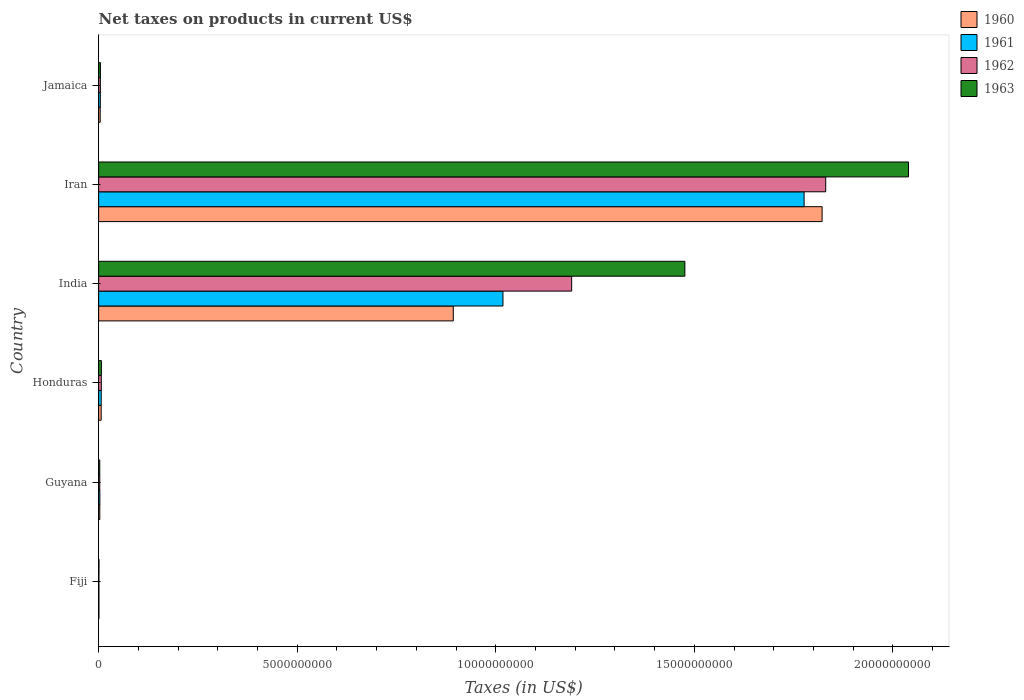How many different coloured bars are there?
Provide a short and direct response. 4. Are the number of bars per tick equal to the number of legend labels?
Provide a succinct answer. Yes. Are the number of bars on each tick of the Y-axis equal?
Keep it short and to the point. Yes. How many bars are there on the 3rd tick from the bottom?
Your answer should be compact. 4. What is the label of the 5th group of bars from the top?
Ensure brevity in your answer.  Guyana. What is the net taxes on products in 1961 in Iran?
Keep it short and to the point. 1.78e+1. Across all countries, what is the maximum net taxes on products in 1963?
Give a very brief answer. 2.04e+1. Across all countries, what is the minimum net taxes on products in 1963?
Offer a very short reply. 8.90e+06. In which country was the net taxes on products in 1962 maximum?
Offer a very short reply. Iran. In which country was the net taxes on products in 1960 minimum?
Give a very brief answer. Fiji. What is the total net taxes on products in 1960 in the graph?
Your answer should be compact. 2.73e+1. What is the difference between the net taxes on products in 1960 in Guyana and that in Honduras?
Give a very brief answer. -3.51e+07. What is the difference between the net taxes on products in 1960 in Fiji and the net taxes on products in 1961 in Iran?
Provide a short and direct response. -1.78e+1. What is the average net taxes on products in 1963 per country?
Make the answer very short. 5.88e+09. What is the difference between the net taxes on products in 1963 and net taxes on products in 1961 in Iran?
Your answer should be very brief. 2.63e+09. In how many countries, is the net taxes on products in 1962 greater than 10000000000 US$?
Ensure brevity in your answer.  2. What is the ratio of the net taxes on products in 1962 in Fiji to that in Iran?
Provide a short and direct response. 0. Is the difference between the net taxes on products in 1963 in Fiji and India greater than the difference between the net taxes on products in 1961 in Fiji and India?
Ensure brevity in your answer.  No. What is the difference between the highest and the second highest net taxes on products in 1960?
Your answer should be compact. 9.29e+09. What is the difference between the highest and the lowest net taxes on products in 1961?
Your answer should be very brief. 1.78e+1. What does the 4th bar from the top in Fiji represents?
Make the answer very short. 1960. What does the 2nd bar from the bottom in India represents?
Keep it short and to the point. 1961. How many countries are there in the graph?
Ensure brevity in your answer.  6. Are the values on the major ticks of X-axis written in scientific E-notation?
Make the answer very short. No. Does the graph contain any zero values?
Your answer should be very brief. No. Where does the legend appear in the graph?
Offer a very short reply. Top right. How many legend labels are there?
Your response must be concise. 4. What is the title of the graph?
Provide a succinct answer. Net taxes on products in current US$. What is the label or title of the X-axis?
Offer a terse response. Taxes (in US$). What is the label or title of the Y-axis?
Offer a very short reply. Country. What is the Taxes (in US$) of 1960 in Fiji?
Your answer should be compact. 6.80e+06. What is the Taxes (in US$) in 1961 in Fiji?
Offer a terse response. 6.80e+06. What is the Taxes (in US$) in 1962 in Fiji?
Give a very brief answer. 7.40e+06. What is the Taxes (in US$) in 1963 in Fiji?
Offer a terse response. 8.90e+06. What is the Taxes (in US$) of 1960 in Guyana?
Offer a terse response. 2.94e+07. What is the Taxes (in US$) of 1961 in Guyana?
Provide a succinct answer. 3.07e+07. What is the Taxes (in US$) in 1962 in Guyana?
Give a very brief answer. 2.90e+07. What is the Taxes (in US$) of 1963 in Guyana?
Offer a terse response. 2.82e+07. What is the Taxes (in US$) of 1960 in Honduras?
Provide a short and direct response. 6.45e+07. What is the Taxes (in US$) in 1961 in Honduras?
Keep it short and to the point. 6.50e+07. What is the Taxes (in US$) of 1962 in Honduras?
Provide a succinct answer. 6.73e+07. What is the Taxes (in US$) of 1963 in Honduras?
Offer a terse response. 6.96e+07. What is the Taxes (in US$) in 1960 in India?
Keep it short and to the point. 8.93e+09. What is the Taxes (in US$) of 1961 in India?
Give a very brief answer. 1.02e+1. What is the Taxes (in US$) of 1962 in India?
Provide a short and direct response. 1.19e+1. What is the Taxes (in US$) in 1963 in India?
Keep it short and to the point. 1.48e+1. What is the Taxes (in US$) of 1960 in Iran?
Ensure brevity in your answer.  1.82e+1. What is the Taxes (in US$) of 1961 in Iran?
Give a very brief answer. 1.78e+1. What is the Taxes (in US$) of 1962 in Iran?
Give a very brief answer. 1.83e+1. What is the Taxes (in US$) in 1963 in Iran?
Offer a terse response. 2.04e+1. What is the Taxes (in US$) of 1960 in Jamaica?
Make the answer very short. 3.93e+07. What is the Taxes (in US$) in 1961 in Jamaica?
Keep it short and to the point. 4.26e+07. What is the Taxes (in US$) in 1962 in Jamaica?
Offer a very short reply. 4.35e+07. What is the Taxes (in US$) in 1963 in Jamaica?
Keep it short and to the point. 4.54e+07. Across all countries, what is the maximum Taxes (in US$) in 1960?
Keep it short and to the point. 1.82e+1. Across all countries, what is the maximum Taxes (in US$) in 1961?
Give a very brief answer. 1.78e+1. Across all countries, what is the maximum Taxes (in US$) in 1962?
Offer a terse response. 1.83e+1. Across all countries, what is the maximum Taxes (in US$) in 1963?
Offer a very short reply. 2.04e+1. Across all countries, what is the minimum Taxes (in US$) of 1960?
Give a very brief answer. 6.80e+06. Across all countries, what is the minimum Taxes (in US$) in 1961?
Your response must be concise. 6.80e+06. Across all countries, what is the minimum Taxes (in US$) of 1962?
Offer a very short reply. 7.40e+06. Across all countries, what is the minimum Taxes (in US$) of 1963?
Provide a short and direct response. 8.90e+06. What is the total Taxes (in US$) in 1960 in the graph?
Make the answer very short. 2.73e+1. What is the total Taxes (in US$) in 1961 in the graph?
Ensure brevity in your answer.  2.81e+1. What is the total Taxes (in US$) of 1962 in the graph?
Give a very brief answer. 3.04e+1. What is the total Taxes (in US$) of 1963 in the graph?
Your response must be concise. 3.53e+1. What is the difference between the Taxes (in US$) in 1960 in Fiji and that in Guyana?
Provide a short and direct response. -2.26e+07. What is the difference between the Taxes (in US$) of 1961 in Fiji and that in Guyana?
Ensure brevity in your answer.  -2.39e+07. What is the difference between the Taxes (in US$) in 1962 in Fiji and that in Guyana?
Give a very brief answer. -2.16e+07. What is the difference between the Taxes (in US$) in 1963 in Fiji and that in Guyana?
Offer a terse response. -1.93e+07. What is the difference between the Taxes (in US$) in 1960 in Fiji and that in Honduras?
Provide a short and direct response. -5.77e+07. What is the difference between the Taxes (in US$) of 1961 in Fiji and that in Honduras?
Give a very brief answer. -5.82e+07. What is the difference between the Taxes (in US$) in 1962 in Fiji and that in Honduras?
Provide a succinct answer. -5.99e+07. What is the difference between the Taxes (in US$) of 1963 in Fiji and that in Honduras?
Your response must be concise. -6.07e+07. What is the difference between the Taxes (in US$) in 1960 in Fiji and that in India?
Your response must be concise. -8.92e+09. What is the difference between the Taxes (in US$) of 1961 in Fiji and that in India?
Keep it short and to the point. -1.02e+1. What is the difference between the Taxes (in US$) in 1962 in Fiji and that in India?
Provide a succinct answer. -1.19e+1. What is the difference between the Taxes (in US$) in 1963 in Fiji and that in India?
Offer a terse response. -1.48e+1. What is the difference between the Taxes (in US$) in 1960 in Fiji and that in Iran?
Make the answer very short. -1.82e+1. What is the difference between the Taxes (in US$) of 1961 in Fiji and that in Iran?
Your answer should be compact. -1.78e+1. What is the difference between the Taxes (in US$) in 1962 in Fiji and that in Iran?
Ensure brevity in your answer.  -1.83e+1. What is the difference between the Taxes (in US$) in 1963 in Fiji and that in Iran?
Keep it short and to the point. -2.04e+1. What is the difference between the Taxes (in US$) in 1960 in Fiji and that in Jamaica?
Make the answer very short. -3.25e+07. What is the difference between the Taxes (in US$) of 1961 in Fiji and that in Jamaica?
Give a very brief answer. -3.58e+07. What is the difference between the Taxes (in US$) in 1962 in Fiji and that in Jamaica?
Your answer should be very brief. -3.61e+07. What is the difference between the Taxes (in US$) of 1963 in Fiji and that in Jamaica?
Give a very brief answer. -3.65e+07. What is the difference between the Taxes (in US$) in 1960 in Guyana and that in Honduras?
Provide a short and direct response. -3.51e+07. What is the difference between the Taxes (in US$) in 1961 in Guyana and that in Honduras?
Your response must be concise. -3.43e+07. What is the difference between the Taxes (in US$) in 1962 in Guyana and that in Honduras?
Your answer should be compact. -3.83e+07. What is the difference between the Taxes (in US$) in 1963 in Guyana and that in Honduras?
Give a very brief answer. -4.14e+07. What is the difference between the Taxes (in US$) in 1960 in Guyana and that in India?
Provide a succinct answer. -8.90e+09. What is the difference between the Taxes (in US$) in 1961 in Guyana and that in India?
Offer a terse response. -1.01e+1. What is the difference between the Taxes (in US$) in 1962 in Guyana and that in India?
Your response must be concise. -1.19e+1. What is the difference between the Taxes (in US$) in 1963 in Guyana and that in India?
Make the answer very short. -1.47e+1. What is the difference between the Taxes (in US$) in 1960 in Guyana and that in Iran?
Ensure brevity in your answer.  -1.82e+1. What is the difference between the Taxes (in US$) in 1961 in Guyana and that in Iran?
Keep it short and to the point. -1.77e+1. What is the difference between the Taxes (in US$) of 1962 in Guyana and that in Iran?
Keep it short and to the point. -1.83e+1. What is the difference between the Taxes (in US$) of 1963 in Guyana and that in Iran?
Your answer should be very brief. -2.04e+1. What is the difference between the Taxes (in US$) in 1960 in Guyana and that in Jamaica?
Your answer should be very brief. -9.90e+06. What is the difference between the Taxes (in US$) of 1961 in Guyana and that in Jamaica?
Provide a short and direct response. -1.19e+07. What is the difference between the Taxes (in US$) in 1962 in Guyana and that in Jamaica?
Your response must be concise. -1.45e+07. What is the difference between the Taxes (in US$) in 1963 in Guyana and that in Jamaica?
Your answer should be compact. -1.72e+07. What is the difference between the Taxes (in US$) of 1960 in Honduras and that in India?
Your answer should be very brief. -8.87e+09. What is the difference between the Taxes (in US$) of 1961 in Honduras and that in India?
Give a very brief answer. -1.01e+1. What is the difference between the Taxes (in US$) of 1962 in Honduras and that in India?
Your answer should be very brief. -1.18e+1. What is the difference between the Taxes (in US$) of 1963 in Honduras and that in India?
Give a very brief answer. -1.47e+1. What is the difference between the Taxes (in US$) of 1960 in Honduras and that in Iran?
Your response must be concise. -1.82e+1. What is the difference between the Taxes (in US$) in 1961 in Honduras and that in Iran?
Your answer should be very brief. -1.77e+1. What is the difference between the Taxes (in US$) in 1962 in Honduras and that in Iran?
Offer a terse response. -1.82e+1. What is the difference between the Taxes (in US$) in 1963 in Honduras and that in Iran?
Your answer should be compact. -2.03e+1. What is the difference between the Taxes (in US$) of 1960 in Honduras and that in Jamaica?
Ensure brevity in your answer.  2.52e+07. What is the difference between the Taxes (in US$) in 1961 in Honduras and that in Jamaica?
Make the answer very short. 2.24e+07. What is the difference between the Taxes (in US$) in 1962 in Honduras and that in Jamaica?
Your answer should be very brief. 2.38e+07. What is the difference between the Taxes (in US$) of 1963 in Honduras and that in Jamaica?
Your answer should be very brief. 2.42e+07. What is the difference between the Taxes (in US$) of 1960 in India and that in Iran?
Provide a short and direct response. -9.29e+09. What is the difference between the Taxes (in US$) in 1961 in India and that in Iran?
Keep it short and to the point. -7.58e+09. What is the difference between the Taxes (in US$) of 1962 in India and that in Iran?
Your response must be concise. -6.40e+09. What is the difference between the Taxes (in US$) in 1963 in India and that in Iran?
Give a very brief answer. -5.63e+09. What is the difference between the Taxes (in US$) of 1960 in India and that in Jamaica?
Give a very brief answer. 8.89e+09. What is the difference between the Taxes (in US$) in 1961 in India and that in Jamaica?
Provide a short and direct response. 1.01e+1. What is the difference between the Taxes (in US$) in 1962 in India and that in Jamaica?
Make the answer very short. 1.19e+1. What is the difference between the Taxes (in US$) in 1963 in India and that in Jamaica?
Keep it short and to the point. 1.47e+1. What is the difference between the Taxes (in US$) of 1960 in Iran and that in Jamaica?
Make the answer very short. 1.82e+1. What is the difference between the Taxes (in US$) in 1961 in Iran and that in Jamaica?
Your answer should be compact. 1.77e+1. What is the difference between the Taxes (in US$) of 1962 in Iran and that in Jamaica?
Offer a very short reply. 1.83e+1. What is the difference between the Taxes (in US$) in 1963 in Iran and that in Jamaica?
Keep it short and to the point. 2.03e+1. What is the difference between the Taxes (in US$) in 1960 in Fiji and the Taxes (in US$) in 1961 in Guyana?
Your answer should be very brief. -2.39e+07. What is the difference between the Taxes (in US$) of 1960 in Fiji and the Taxes (in US$) of 1962 in Guyana?
Offer a terse response. -2.22e+07. What is the difference between the Taxes (in US$) of 1960 in Fiji and the Taxes (in US$) of 1963 in Guyana?
Offer a very short reply. -2.14e+07. What is the difference between the Taxes (in US$) in 1961 in Fiji and the Taxes (in US$) in 1962 in Guyana?
Give a very brief answer. -2.22e+07. What is the difference between the Taxes (in US$) in 1961 in Fiji and the Taxes (in US$) in 1963 in Guyana?
Give a very brief answer. -2.14e+07. What is the difference between the Taxes (in US$) of 1962 in Fiji and the Taxes (in US$) of 1963 in Guyana?
Your answer should be very brief. -2.08e+07. What is the difference between the Taxes (in US$) of 1960 in Fiji and the Taxes (in US$) of 1961 in Honduras?
Keep it short and to the point. -5.82e+07. What is the difference between the Taxes (in US$) in 1960 in Fiji and the Taxes (in US$) in 1962 in Honduras?
Your response must be concise. -6.05e+07. What is the difference between the Taxes (in US$) in 1960 in Fiji and the Taxes (in US$) in 1963 in Honduras?
Offer a very short reply. -6.28e+07. What is the difference between the Taxes (in US$) of 1961 in Fiji and the Taxes (in US$) of 1962 in Honduras?
Provide a succinct answer. -6.05e+07. What is the difference between the Taxes (in US$) of 1961 in Fiji and the Taxes (in US$) of 1963 in Honduras?
Provide a short and direct response. -6.28e+07. What is the difference between the Taxes (in US$) of 1962 in Fiji and the Taxes (in US$) of 1963 in Honduras?
Your answer should be compact. -6.22e+07. What is the difference between the Taxes (in US$) of 1960 in Fiji and the Taxes (in US$) of 1961 in India?
Your answer should be very brief. -1.02e+1. What is the difference between the Taxes (in US$) in 1960 in Fiji and the Taxes (in US$) in 1962 in India?
Provide a short and direct response. -1.19e+1. What is the difference between the Taxes (in US$) in 1960 in Fiji and the Taxes (in US$) in 1963 in India?
Give a very brief answer. -1.48e+1. What is the difference between the Taxes (in US$) of 1961 in Fiji and the Taxes (in US$) of 1962 in India?
Your answer should be very brief. -1.19e+1. What is the difference between the Taxes (in US$) of 1961 in Fiji and the Taxes (in US$) of 1963 in India?
Keep it short and to the point. -1.48e+1. What is the difference between the Taxes (in US$) in 1962 in Fiji and the Taxes (in US$) in 1963 in India?
Your response must be concise. -1.48e+1. What is the difference between the Taxes (in US$) of 1960 in Fiji and the Taxes (in US$) of 1961 in Iran?
Your response must be concise. -1.78e+1. What is the difference between the Taxes (in US$) of 1960 in Fiji and the Taxes (in US$) of 1962 in Iran?
Make the answer very short. -1.83e+1. What is the difference between the Taxes (in US$) of 1960 in Fiji and the Taxes (in US$) of 1963 in Iran?
Your response must be concise. -2.04e+1. What is the difference between the Taxes (in US$) in 1961 in Fiji and the Taxes (in US$) in 1962 in Iran?
Your answer should be very brief. -1.83e+1. What is the difference between the Taxes (in US$) in 1961 in Fiji and the Taxes (in US$) in 1963 in Iran?
Offer a terse response. -2.04e+1. What is the difference between the Taxes (in US$) in 1962 in Fiji and the Taxes (in US$) in 1963 in Iran?
Keep it short and to the point. -2.04e+1. What is the difference between the Taxes (in US$) of 1960 in Fiji and the Taxes (in US$) of 1961 in Jamaica?
Keep it short and to the point. -3.58e+07. What is the difference between the Taxes (in US$) in 1960 in Fiji and the Taxes (in US$) in 1962 in Jamaica?
Provide a short and direct response. -3.67e+07. What is the difference between the Taxes (in US$) of 1960 in Fiji and the Taxes (in US$) of 1963 in Jamaica?
Your answer should be compact. -3.86e+07. What is the difference between the Taxes (in US$) in 1961 in Fiji and the Taxes (in US$) in 1962 in Jamaica?
Provide a succinct answer. -3.67e+07. What is the difference between the Taxes (in US$) of 1961 in Fiji and the Taxes (in US$) of 1963 in Jamaica?
Keep it short and to the point. -3.86e+07. What is the difference between the Taxes (in US$) of 1962 in Fiji and the Taxes (in US$) of 1963 in Jamaica?
Offer a very short reply. -3.80e+07. What is the difference between the Taxes (in US$) of 1960 in Guyana and the Taxes (in US$) of 1961 in Honduras?
Keep it short and to the point. -3.56e+07. What is the difference between the Taxes (in US$) in 1960 in Guyana and the Taxes (in US$) in 1962 in Honduras?
Provide a succinct answer. -3.79e+07. What is the difference between the Taxes (in US$) of 1960 in Guyana and the Taxes (in US$) of 1963 in Honduras?
Your response must be concise. -4.02e+07. What is the difference between the Taxes (in US$) in 1961 in Guyana and the Taxes (in US$) in 1962 in Honduras?
Provide a succinct answer. -3.66e+07. What is the difference between the Taxes (in US$) of 1961 in Guyana and the Taxes (in US$) of 1963 in Honduras?
Give a very brief answer. -3.89e+07. What is the difference between the Taxes (in US$) of 1962 in Guyana and the Taxes (in US$) of 1963 in Honduras?
Provide a short and direct response. -4.06e+07. What is the difference between the Taxes (in US$) in 1960 in Guyana and the Taxes (in US$) in 1961 in India?
Make the answer very short. -1.02e+1. What is the difference between the Taxes (in US$) of 1960 in Guyana and the Taxes (in US$) of 1962 in India?
Provide a short and direct response. -1.19e+1. What is the difference between the Taxes (in US$) of 1960 in Guyana and the Taxes (in US$) of 1963 in India?
Your answer should be compact. -1.47e+1. What is the difference between the Taxes (in US$) of 1961 in Guyana and the Taxes (in US$) of 1962 in India?
Make the answer very short. -1.19e+1. What is the difference between the Taxes (in US$) in 1961 in Guyana and the Taxes (in US$) in 1963 in India?
Provide a succinct answer. -1.47e+1. What is the difference between the Taxes (in US$) in 1962 in Guyana and the Taxes (in US$) in 1963 in India?
Offer a terse response. -1.47e+1. What is the difference between the Taxes (in US$) in 1960 in Guyana and the Taxes (in US$) in 1961 in Iran?
Your response must be concise. -1.77e+1. What is the difference between the Taxes (in US$) of 1960 in Guyana and the Taxes (in US$) of 1962 in Iran?
Ensure brevity in your answer.  -1.83e+1. What is the difference between the Taxes (in US$) in 1960 in Guyana and the Taxes (in US$) in 1963 in Iran?
Offer a very short reply. -2.04e+1. What is the difference between the Taxes (in US$) of 1961 in Guyana and the Taxes (in US$) of 1962 in Iran?
Your answer should be compact. -1.83e+1. What is the difference between the Taxes (in US$) in 1961 in Guyana and the Taxes (in US$) in 1963 in Iran?
Your answer should be very brief. -2.04e+1. What is the difference between the Taxes (in US$) in 1962 in Guyana and the Taxes (in US$) in 1963 in Iran?
Ensure brevity in your answer.  -2.04e+1. What is the difference between the Taxes (in US$) in 1960 in Guyana and the Taxes (in US$) in 1961 in Jamaica?
Offer a terse response. -1.32e+07. What is the difference between the Taxes (in US$) in 1960 in Guyana and the Taxes (in US$) in 1962 in Jamaica?
Your answer should be compact. -1.41e+07. What is the difference between the Taxes (in US$) in 1960 in Guyana and the Taxes (in US$) in 1963 in Jamaica?
Offer a terse response. -1.60e+07. What is the difference between the Taxes (in US$) of 1961 in Guyana and the Taxes (in US$) of 1962 in Jamaica?
Keep it short and to the point. -1.28e+07. What is the difference between the Taxes (in US$) in 1961 in Guyana and the Taxes (in US$) in 1963 in Jamaica?
Your answer should be very brief. -1.47e+07. What is the difference between the Taxes (in US$) of 1962 in Guyana and the Taxes (in US$) of 1963 in Jamaica?
Ensure brevity in your answer.  -1.64e+07. What is the difference between the Taxes (in US$) in 1960 in Honduras and the Taxes (in US$) in 1961 in India?
Your answer should be compact. -1.01e+1. What is the difference between the Taxes (in US$) in 1960 in Honduras and the Taxes (in US$) in 1962 in India?
Provide a succinct answer. -1.18e+1. What is the difference between the Taxes (in US$) of 1960 in Honduras and the Taxes (in US$) of 1963 in India?
Your answer should be very brief. -1.47e+1. What is the difference between the Taxes (in US$) in 1961 in Honduras and the Taxes (in US$) in 1962 in India?
Offer a very short reply. -1.18e+1. What is the difference between the Taxes (in US$) of 1961 in Honduras and the Taxes (in US$) of 1963 in India?
Your response must be concise. -1.47e+1. What is the difference between the Taxes (in US$) of 1962 in Honduras and the Taxes (in US$) of 1963 in India?
Your answer should be compact. -1.47e+1. What is the difference between the Taxes (in US$) in 1960 in Honduras and the Taxes (in US$) in 1961 in Iran?
Your response must be concise. -1.77e+1. What is the difference between the Taxes (in US$) of 1960 in Honduras and the Taxes (in US$) of 1962 in Iran?
Ensure brevity in your answer.  -1.82e+1. What is the difference between the Taxes (in US$) of 1960 in Honduras and the Taxes (in US$) of 1963 in Iran?
Your response must be concise. -2.03e+1. What is the difference between the Taxes (in US$) of 1961 in Honduras and the Taxes (in US$) of 1962 in Iran?
Give a very brief answer. -1.82e+1. What is the difference between the Taxes (in US$) in 1961 in Honduras and the Taxes (in US$) in 1963 in Iran?
Give a very brief answer. -2.03e+1. What is the difference between the Taxes (in US$) in 1962 in Honduras and the Taxes (in US$) in 1963 in Iran?
Make the answer very short. -2.03e+1. What is the difference between the Taxes (in US$) in 1960 in Honduras and the Taxes (in US$) in 1961 in Jamaica?
Your answer should be very brief. 2.19e+07. What is the difference between the Taxes (in US$) of 1960 in Honduras and the Taxes (in US$) of 1962 in Jamaica?
Ensure brevity in your answer.  2.10e+07. What is the difference between the Taxes (in US$) of 1960 in Honduras and the Taxes (in US$) of 1963 in Jamaica?
Offer a terse response. 1.91e+07. What is the difference between the Taxes (in US$) of 1961 in Honduras and the Taxes (in US$) of 1962 in Jamaica?
Keep it short and to the point. 2.15e+07. What is the difference between the Taxes (in US$) in 1961 in Honduras and the Taxes (in US$) in 1963 in Jamaica?
Your response must be concise. 1.96e+07. What is the difference between the Taxes (in US$) in 1962 in Honduras and the Taxes (in US$) in 1963 in Jamaica?
Your answer should be compact. 2.19e+07. What is the difference between the Taxes (in US$) of 1960 in India and the Taxes (in US$) of 1961 in Iran?
Give a very brief answer. -8.83e+09. What is the difference between the Taxes (in US$) of 1960 in India and the Taxes (in US$) of 1962 in Iran?
Provide a succinct answer. -9.38e+09. What is the difference between the Taxes (in US$) in 1960 in India and the Taxes (in US$) in 1963 in Iran?
Make the answer very short. -1.15e+1. What is the difference between the Taxes (in US$) in 1961 in India and the Taxes (in US$) in 1962 in Iran?
Provide a short and direct response. -8.13e+09. What is the difference between the Taxes (in US$) in 1961 in India and the Taxes (in US$) in 1963 in Iran?
Your response must be concise. -1.02e+1. What is the difference between the Taxes (in US$) in 1962 in India and the Taxes (in US$) in 1963 in Iran?
Provide a succinct answer. -8.48e+09. What is the difference between the Taxes (in US$) of 1960 in India and the Taxes (in US$) of 1961 in Jamaica?
Offer a terse response. 8.89e+09. What is the difference between the Taxes (in US$) in 1960 in India and the Taxes (in US$) in 1962 in Jamaica?
Provide a succinct answer. 8.89e+09. What is the difference between the Taxes (in US$) in 1960 in India and the Taxes (in US$) in 1963 in Jamaica?
Give a very brief answer. 8.88e+09. What is the difference between the Taxes (in US$) of 1961 in India and the Taxes (in US$) of 1962 in Jamaica?
Provide a short and direct response. 1.01e+1. What is the difference between the Taxes (in US$) of 1961 in India and the Taxes (in US$) of 1963 in Jamaica?
Provide a short and direct response. 1.01e+1. What is the difference between the Taxes (in US$) in 1962 in India and the Taxes (in US$) in 1963 in Jamaica?
Provide a short and direct response. 1.19e+1. What is the difference between the Taxes (in US$) of 1960 in Iran and the Taxes (in US$) of 1961 in Jamaica?
Ensure brevity in your answer.  1.82e+1. What is the difference between the Taxes (in US$) in 1960 in Iran and the Taxes (in US$) in 1962 in Jamaica?
Offer a very short reply. 1.82e+1. What is the difference between the Taxes (in US$) of 1960 in Iran and the Taxes (in US$) of 1963 in Jamaica?
Your answer should be very brief. 1.82e+1. What is the difference between the Taxes (in US$) of 1961 in Iran and the Taxes (in US$) of 1962 in Jamaica?
Provide a short and direct response. 1.77e+1. What is the difference between the Taxes (in US$) of 1961 in Iran and the Taxes (in US$) of 1963 in Jamaica?
Your response must be concise. 1.77e+1. What is the difference between the Taxes (in US$) of 1962 in Iran and the Taxes (in US$) of 1963 in Jamaica?
Your answer should be very brief. 1.83e+1. What is the average Taxes (in US$) in 1960 per country?
Keep it short and to the point. 4.55e+09. What is the average Taxes (in US$) in 1961 per country?
Your response must be concise. 4.68e+09. What is the average Taxes (in US$) of 1962 per country?
Make the answer very short. 5.06e+09. What is the average Taxes (in US$) in 1963 per country?
Your answer should be very brief. 5.88e+09. What is the difference between the Taxes (in US$) of 1960 and Taxes (in US$) of 1961 in Fiji?
Provide a succinct answer. 0. What is the difference between the Taxes (in US$) of 1960 and Taxes (in US$) of 1962 in Fiji?
Make the answer very short. -6.00e+05. What is the difference between the Taxes (in US$) of 1960 and Taxes (in US$) of 1963 in Fiji?
Offer a terse response. -2.10e+06. What is the difference between the Taxes (in US$) of 1961 and Taxes (in US$) of 1962 in Fiji?
Your answer should be very brief. -6.00e+05. What is the difference between the Taxes (in US$) of 1961 and Taxes (in US$) of 1963 in Fiji?
Give a very brief answer. -2.10e+06. What is the difference between the Taxes (in US$) in 1962 and Taxes (in US$) in 1963 in Fiji?
Give a very brief answer. -1.50e+06. What is the difference between the Taxes (in US$) in 1960 and Taxes (in US$) in 1961 in Guyana?
Provide a succinct answer. -1.30e+06. What is the difference between the Taxes (in US$) in 1960 and Taxes (in US$) in 1962 in Guyana?
Your response must be concise. 4.00e+05. What is the difference between the Taxes (in US$) in 1960 and Taxes (in US$) in 1963 in Guyana?
Your answer should be compact. 1.20e+06. What is the difference between the Taxes (in US$) in 1961 and Taxes (in US$) in 1962 in Guyana?
Your answer should be very brief. 1.70e+06. What is the difference between the Taxes (in US$) in 1961 and Taxes (in US$) in 1963 in Guyana?
Ensure brevity in your answer.  2.50e+06. What is the difference between the Taxes (in US$) of 1960 and Taxes (in US$) of 1961 in Honduras?
Offer a very short reply. -5.00e+05. What is the difference between the Taxes (in US$) of 1960 and Taxes (in US$) of 1962 in Honduras?
Offer a terse response. -2.80e+06. What is the difference between the Taxes (in US$) in 1960 and Taxes (in US$) in 1963 in Honduras?
Provide a short and direct response. -5.10e+06. What is the difference between the Taxes (in US$) in 1961 and Taxes (in US$) in 1962 in Honduras?
Give a very brief answer. -2.30e+06. What is the difference between the Taxes (in US$) in 1961 and Taxes (in US$) in 1963 in Honduras?
Give a very brief answer. -4.60e+06. What is the difference between the Taxes (in US$) of 1962 and Taxes (in US$) of 1963 in Honduras?
Offer a very short reply. -2.30e+06. What is the difference between the Taxes (in US$) in 1960 and Taxes (in US$) in 1961 in India?
Your response must be concise. -1.25e+09. What is the difference between the Taxes (in US$) of 1960 and Taxes (in US$) of 1962 in India?
Offer a very short reply. -2.98e+09. What is the difference between the Taxes (in US$) of 1960 and Taxes (in US$) of 1963 in India?
Offer a very short reply. -5.83e+09. What is the difference between the Taxes (in US$) of 1961 and Taxes (in US$) of 1962 in India?
Provide a short and direct response. -1.73e+09. What is the difference between the Taxes (in US$) of 1961 and Taxes (in US$) of 1963 in India?
Make the answer very short. -4.58e+09. What is the difference between the Taxes (in US$) in 1962 and Taxes (in US$) in 1963 in India?
Your response must be concise. -2.85e+09. What is the difference between the Taxes (in US$) in 1960 and Taxes (in US$) in 1961 in Iran?
Your answer should be very brief. 4.53e+08. What is the difference between the Taxes (in US$) in 1960 and Taxes (in US$) in 1962 in Iran?
Offer a terse response. -9.06e+07. What is the difference between the Taxes (in US$) of 1960 and Taxes (in US$) of 1963 in Iran?
Keep it short and to the point. -2.18e+09. What is the difference between the Taxes (in US$) of 1961 and Taxes (in US$) of 1962 in Iran?
Provide a short and direct response. -5.44e+08. What is the difference between the Taxes (in US$) of 1961 and Taxes (in US$) of 1963 in Iran?
Give a very brief answer. -2.63e+09. What is the difference between the Taxes (in US$) of 1962 and Taxes (in US$) of 1963 in Iran?
Ensure brevity in your answer.  -2.08e+09. What is the difference between the Taxes (in US$) in 1960 and Taxes (in US$) in 1961 in Jamaica?
Provide a short and direct response. -3.30e+06. What is the difference between the Taxes (in US$) of 1960 and Taxes (in US$) of 1962 in Jamaica?
Keep it short and to the point. -4.20e+06. What is the difference between the Taxes (in US$) in 1960 and Taxes (in US$) in 1963 in Jamaica?
Your response must be concise. -6.10e+06. What is the difference between the Taxes (in US$) in 1961 and Taxes (in US$) in 1962 in Jamaica?
Ensure brevity in your answer.  -9.00e+05. What is the difference between the Taxes (in US$) in 1961 and Taxes (in US$) in 1963 in Jamaica?
Offer a terse response. -2.80e+06. What is the difference between the Taxes (in US$) of 1962 and Taxes (in US$) of 1963 in Jamaica?
Provide a short and direct response. -1.90e+06. What is the ratio of the Taxes (in US$) in 1960 in Fiji to that in Guyana?
Provide a succinct answer. 0.23. What is the ratio of the Taxes (in US$) in 1961 in Fiji to that in Guyana?
Make the answer very short. 0.22. What is the ratio of the Taxes (in US$) of 1962 in Fiji to that in Guyana?
Provide a short and direct response. 0.26. What is the ratio of the Taxes (in US$) in 1963 in Fiji to that in Guyana?
Offer a very short reply. 0.32. What is the ratio of the Taxes (in US$) of 1960 in Fiji to that in Honduras?
Your answer should be compact. 0.11. What is the ratio of the Taxes (in US$) of 1961 in Fiji to that in Honduras?
Your response must be concise. 0.1. What is the ratio of the Taxes (in US$) of 1962 in Fiji to that in Honduras?
Ensure brevity in your answer.  0.11. What is the ratio of the Taxes (in US$) in 1963 in Fiji to that in Honduras?
Give a very brief answer. 0.13. What is the ratio of the Taxes (in US$) of 1960 in Fiji to that in India?
Provide a succinct answer. 0. What is the ratio of the Taxes (in US$) in 1961 in Fiji to that in India?
Your answer should be compact. 0. What is the ratio of the Taxes (in US$) in 1962 in Fiji to that in India?
Ensure brevity in your answer.  0. What is the ratio of the Taxes (in US$) in 1963 in Fiji to that in India?
Offer a very short reply. 0. What is the ratio of the Taxes (in US$) in 1962 in Fiji to that in Iran?
Make the answer very short. 0. What is the ratio of the Taxes (in US$) in 1963 in Fiji to that in Iran?
Provide a succinct answer. 0. What is the ratio of the Taxes (in US$) in 1960 in Fiji to that in Jamaica?
Ensure brevity in your answer.  0.17. What is the ratio of the Taxes (in US$) in 1961 in Fiji to that in Jamaica?
Provide a short and direct response. 0.16. What is the ratio of the Taxes (in US$) in 1962 in Fiji to that in Jamaica?
Offer a terse response. 0.17. What is the ratio of the Taxes (in US$) in 1963 in Fiji to that in Jamaica?
Offer a very short reply. 0.2. What is the ratio of the Taxes (in US$) of 1960 in Guyana to that in Honduras?
Keep it short and to the point. 0.46. What is the ratio of the Taxes (in US$) in 1961 in Guyana to that in Honduras?
Ensure brevity in your answer.  0.47. What is the ratio of the Taxes (in US$) of 1962 in Guyana to that in Honduras?
Offer a very short reply. 0.43. What is the ratio of the Taxes (in US$) in 1963 in Guyana to that in Honduras?
Offer a very short reply. 0.41. What is the ratio of the Taxes (in US$) of 1960 in Guyana to that in India?
Provide a succinct answer. 0. What is the ratio of the Taxes (in US$) of 1961 in Guyana to that in India?
Provide a succinct answer. 0. What is the ratio of the Taxes (in US$) of 1962 in Guyana to that in India?
Your response must be concise. 0. What is the ratio of the Taxes (in US$) of 1963 in Guyana to that in India?
Provide a short and direct response. 0. What is the ratio of the Taxes (in US$) in 1960 in Guyana to that in Iran?
Provide a succinct answer. 0. What is the ratio of the Taxes (in US$) in 1961 in Guyana to that in Iran?
Give a very brief answer. 0. What is the ratio of the Taxes (in US$) of 1962 in Guyana to that in Iran?
Make the answer very short. 0. What is the ratio of the Taxes (in US$) in 1963 in Guyana to that in Iran?
Provide a succinct answer. 0. What is the ratio of the Taxes (in US$) in 1960 in Guyana to that in Jamaica?
Offer a very short reply. 0.75. What is the ratio of the Taxes (in US$) in 1961 in Guyana to that in Jamaica?
Your answer should be compact. 0.72. What is the ratio of the Taxes (in US$) of 1963 in Guyana to that in Jamaica?
Make the answer very short. 0.62. What is the ratio of the Taxes (in US$) in 1960 in Honduras to that in India?
Your answer should be very brief. 0.01. What is the ratio of the Taxes (in US$) in 1961 in Honduras to that in India?
Give a very brief answer. 0.01. What is the ratio of the Taxes (in US$) of 1962 in Honduras to that in India?
Ensure brevity in your answer.  0.01. What is the ratio of the Taxes (in US$) in 1963 in Honduras to that in India?
Provide a succinct answer. 0. What is the ratio of the Taxes (in US$) in 1960 in Honduras to that in Iran?
Offer a very short reply. 0. What is the ratio of the Taxes (in US$) of 1961 in Honduras to that in Iran?
Give a very brief answer. 0. What is the ratio of the Taxes (in US$) in 1962 in Honduras to that in Iran?
Your answer should be very brief. 0. What is the ratio of the Taxes (in US$) of 1963 in Honduras to that in Iran?
Offer a very short reply. 0. What is the ratio of the Taxes (in US$) of 1960 in Honduras to that in Jamaica?
Ensure brevity in your answer.  1.64. What is the ratio of the Taxes (in US$) in 1961 in Honduras to that in Jamaica?
Your answer should be compact. 1.53. What is the ratio of the Taxes (in US$) of 1962 in Honduras to that in Jamaica?
Keep it short and to the point. 1.55. What is the ratio of the Taxes (in US$) of 1963 in Honduras to that in Jamaica?
Give a very brief answer. 1.53. What is the ratio of the Taxes (in US$) of 1960 in India to that in Iran?
Your answer should be very brief. 0.49. What is the ratio of the Taxes (in US$) in 1961 in India to that in Iran?
Your answer should be very brief. 0.57. What is the ratio of the Taxes (in US$) in 1962 in India to that in Iran?
Ensure brevity in your answer.  0.65. What is the ratio of the Taxes (in US$) in 1963 in India to that in Iran?
Ensure brevity in your answer.  0.72. What is the ratio of the Taxes (in US$) in 1960 in India to that in Jamaica?
Offer a very short reply. 227.23. What is the ratio of the Taxes (in US$) in 1961 in India to that in Jamaica?
Keep it short and to the point. 238.97. What is the ratio of the Taxes (in US$) of 1962 in India to that in Jamaica?
Provide a short and direct response. 273.79. What is the ratio of the Taxes (in US$) of 1963 in India to that in Jamaica?
Keep it short and to the point. 325.11. What is the ratio of the Taxes (in US$) in 1960 in Iran to that in Jamaica?
Your response must be concise. 463.51. What is the ratio of the Taxes (in US$) in 1961 in Iran to that in Jamaica?
Provide a succinct answer. 416.97. What is the ratio of the Taxes (in US$) in 1962 in Iran to that in Jamaica?
Make the answer very short. 420.84. What is the ratio of the Taxes (in US$) in 1963 in Iran to that in Jamaica?
Make the answer very short. 449.14. What is the difference between the highest and the second highest Taxes (in US$) of 1960?
Keep it short and to the point. 9.29e+09. What is the difference between the highest and the second highest Taxes (in US$) in 1961?
Your response must be concise. 7.58e+09. What is the difference between the highest and the second highest Taxes (in US$) of 1962?
Make the answer very short. 6.40e+09. What is the difference between the highest and the second highest Taxes (in US$) in 1963?
Offer a terse response. 5.63e+09. What is the difference between the highest and the lowest Taxes (in US$) of 1960?
Make the answer very short. 1.82e+1. What is the difference between the highest and the lowest Taxes (in US$) in 1961?
Offer a very short reply. 1.78e+1. What is the difference between the highest and the lowest Taxes (in US$) in 1962?
Your answer should be compact. 1.83e+1. What is the difference between the highest and the lowest Taxes (in US$) in 1963?
Provide a short and direct response. 2.04e+1. 